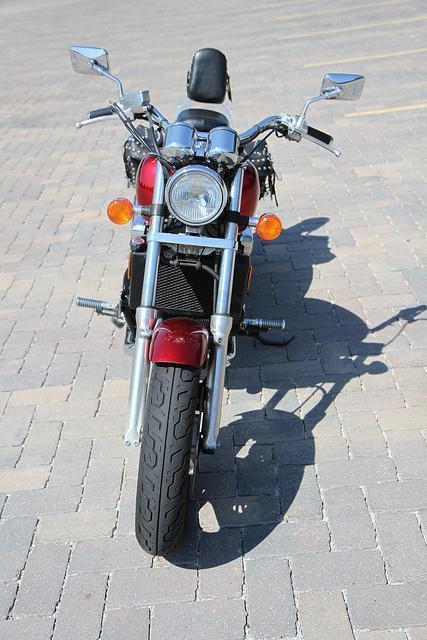How many red color pizza on the bowl?
Give a very brief answer. 0. 